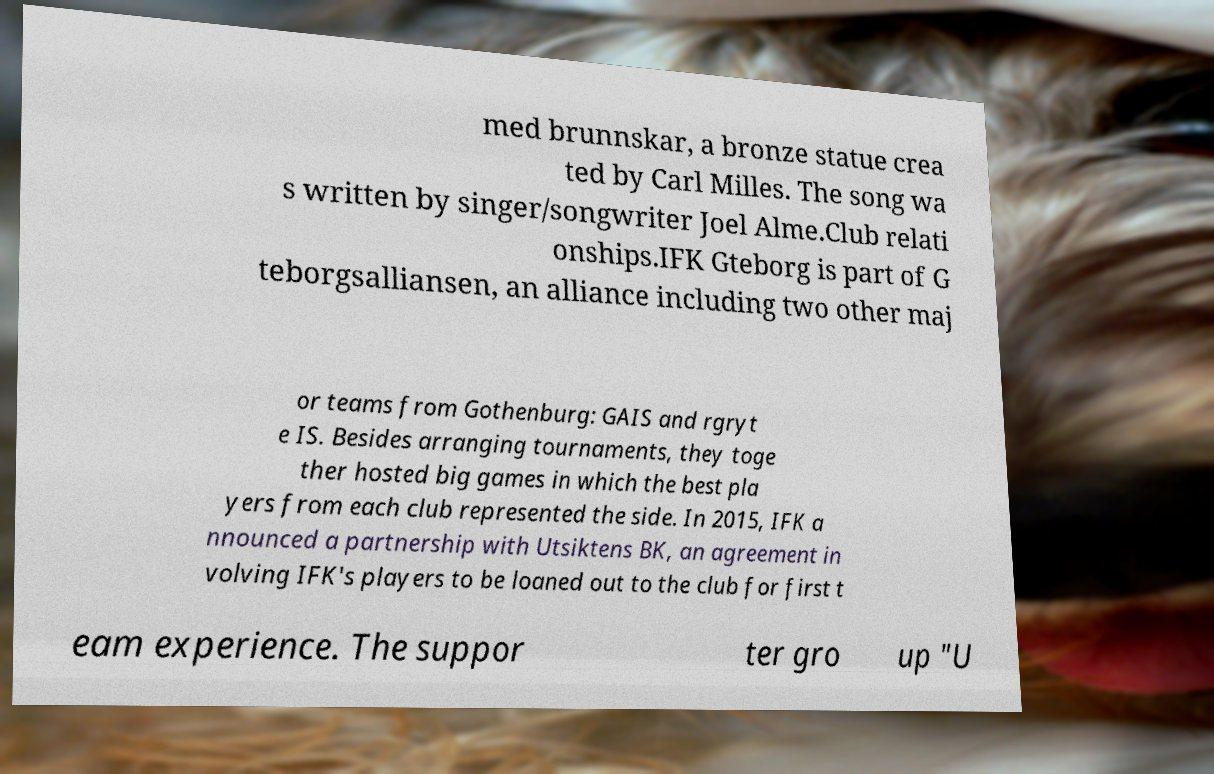For documentation purposes, I need the text within this image transcribed. Could you provide that? med brunnskar, a bronze statue crea ted by Carl Milles. The song wa s written by singer/songwriter Joel Alme.Club relati onships.IFK Gteborg is part of G teborgsalliansen, an alliance including two other maj or teams from Gothenburg: GAIS and rgryt e IS. Besides arranging tournaments, they toge ther hosted big games in which the best pla yers from each club represented the side. In 2015, IFK a nnounced a partnership with Utsiktens BK, an agreement in volving IFK's players to be loaned out to the club for first t eam experience. The suppor ter gro up "U 